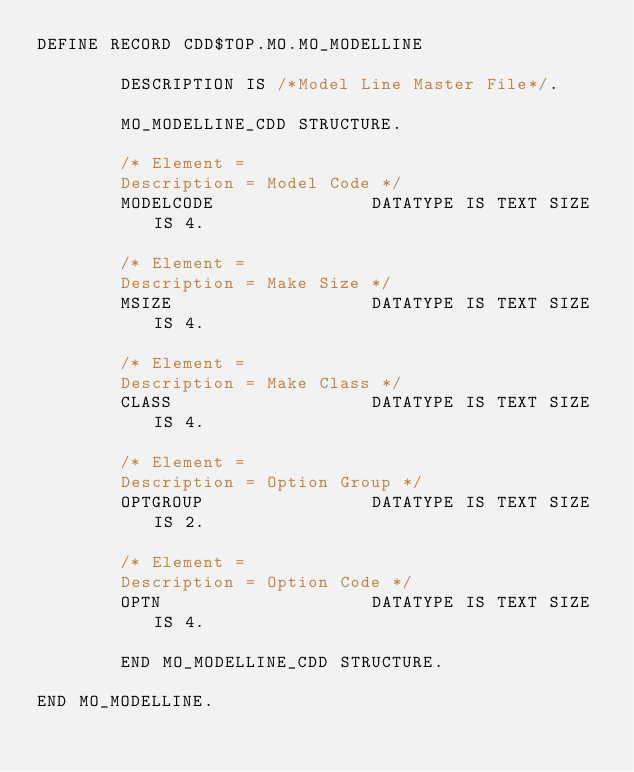Convert code to text. <code><loc_0><loc_0><loc_500><loc_500><_SQL_>DEFINE RECORD CDD$TOP.MO.MO_MODELLINE

        DESCRIPTION IS /*Model Line Master File*/.

        MO_MODELLINE_CDD STRUCTURE.

        /* Element =
        Description = Model Code */
        MODELCODE               DATATYPE IS TEXT SIZE IS 4.

        /* Element =
        Description = Make Size */
        MSIZE                   DATATYPE IS TEXT SIZE IS 4.

        /* Element =
        Description = Make Class */
        CLASS                   DATATYPE IS TEXT SIZE IS 4.

        /* Element =
        Description = Option Group */
        OPTGROUP                DATATYPE IS TEXT SIZE IS 2.

        /* Element =
        Description = Option Code */
        OPTN                    DATATYPE IS TEXT SIZE IS 4.

        END MO_MODELLINE_CDD STRUCTURE.

END MO_MODELLINE.
</code> 